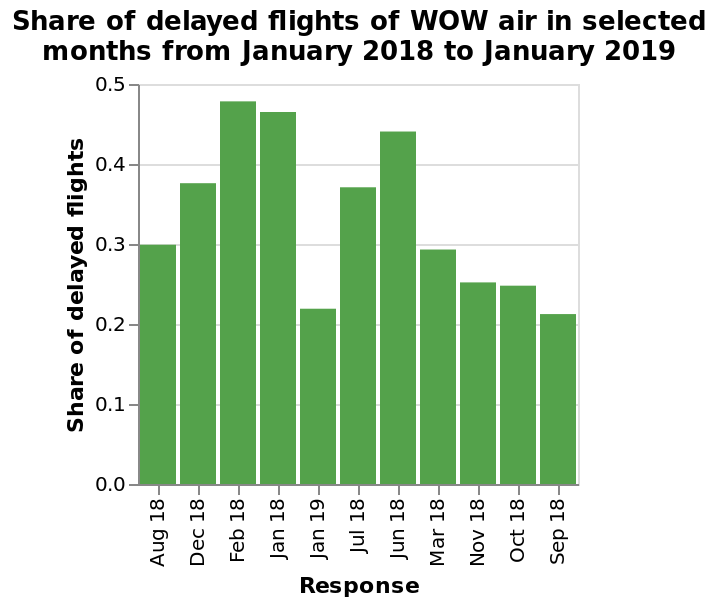<image>
What is shown on the x-axis of the bar plot? The x-axis of the bar plot shows the categorical scale of Response from Aug 18 to Sep 18. 